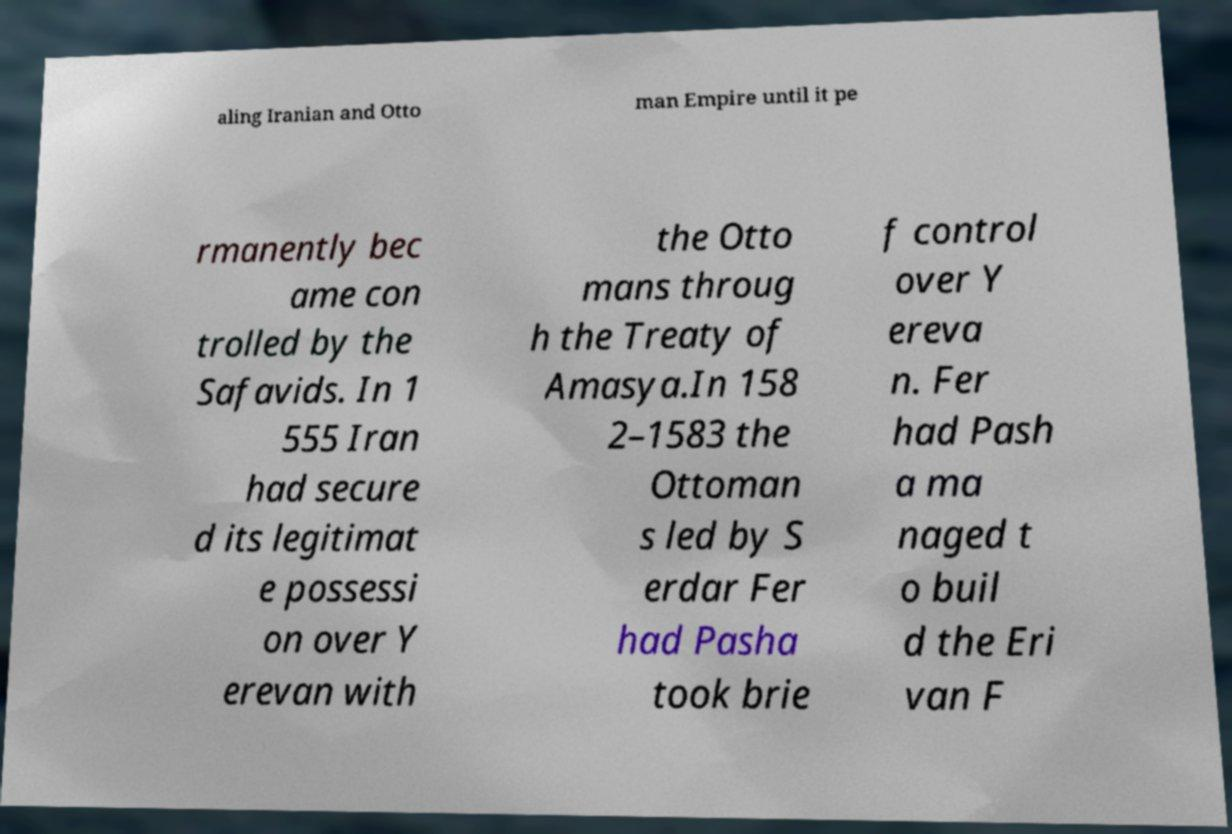What messages or text are displayed in this image? I need them in a readable, typed format. aling Iranian and Otto man Empire until it pe rmanently bec ame con trolled by the Safavids. In 1 555 Iran had secure d its legitimat e possessi on over Y erevan with the Otto mans throug h the Treaty of Amasya.In 158 2–1583 the Ottoman s led by S erdar Fer had Pasha took brie f control over Y ereva n. Fer had Pash a ma naged t o buil d the Eri van F 